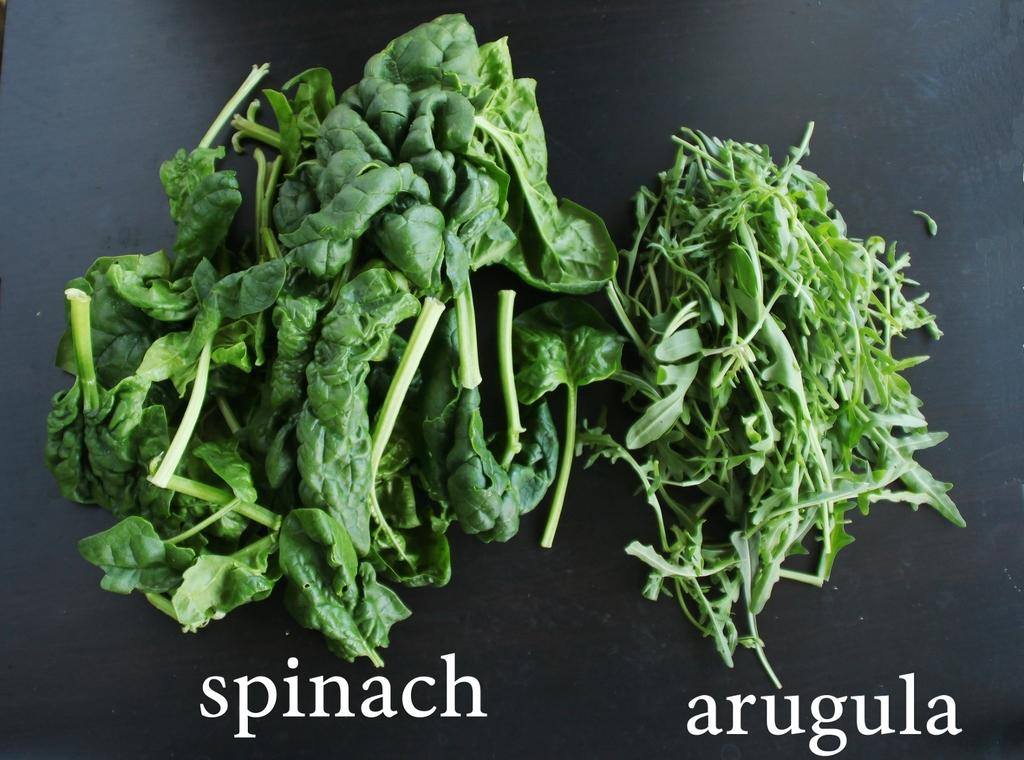What type of food can be seen on the table in the image? There are leafy vegetables on the table in the image. Is there any text present in the image? Yes, there is some text visible in the image. How many beds are visible in the image? There are no beds present in the image. What type of copy is being made in the image? There is no copying or duplication activity depicted in the image. 